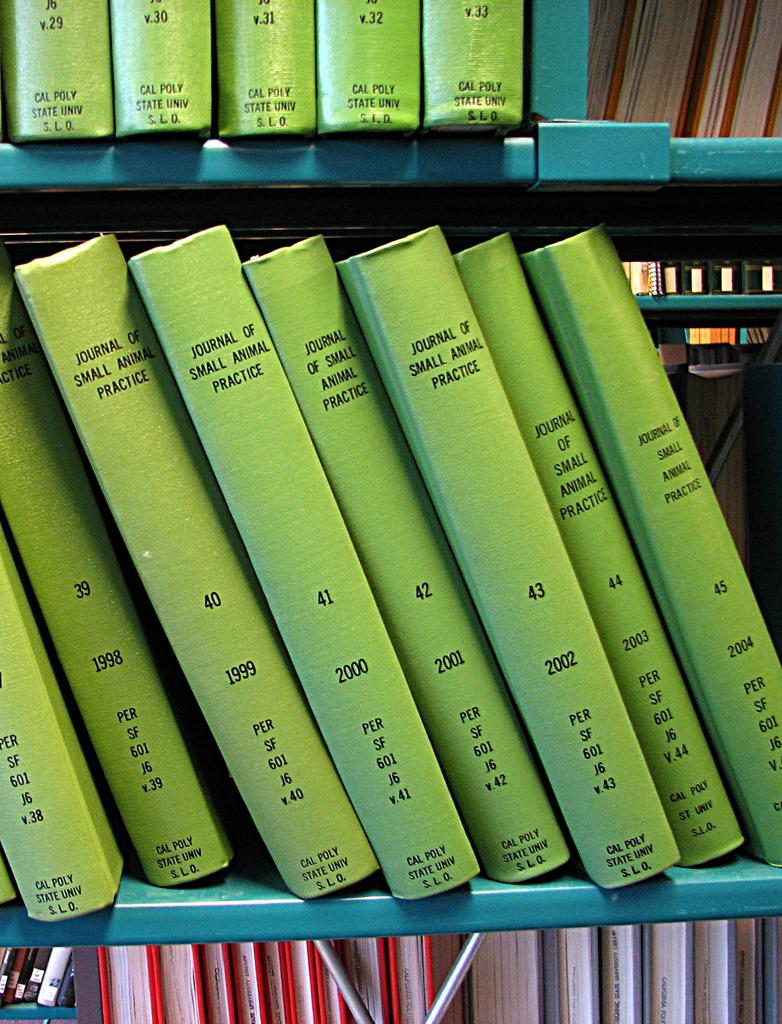Provide a one-sentence caption for the provided image. Several volumes of the Journal of Small Animal Practice, all with green spines. 